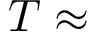Convert formula to latex. <formula><loc_0><loc_0><loc_500><loc_500>T \approx</formula> 